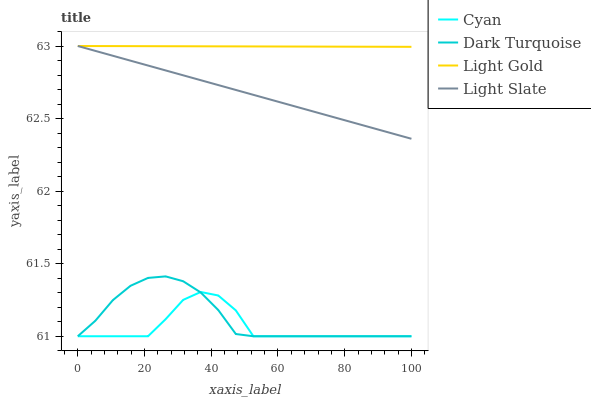Does Cyan have the minimum area under the curve?
Answer yes or no. Yes. Does Light Gold have the maximum area under the curve?
Answer yes or no. Yes. Does Light Gold have the minimum area under the curve?
Answer yes or no. No. Does Cyan have the maximum area under the curve?
Answer yes or no. No. Is Light Slate the smoothest?
Answer yes or no. Yes. Is Cyan the roughest?
Answer yes or no. Yes. Is Light Gold the smoothest?
Answer yes or no. No. Is Light Gold the roughest?
Answer yes or no. No. Does Cyan have the lowest value?
Answer yes or no. Yes. Does Light Gold have the lowest value?
Answer yes or no. No. Does Light Gold have the highest value?
Answer yes or no. Yes. Does Cyan have the highest value?
Answer yes or no. No. Is Dark Turquoise less than Light Gold?
Answer yes or no. Yes. Is Light Gold greater than Dark Turquoise?
Answer yes or no. Yes. Does Light Slate intersect Light Gold?
Answer yes or no. Yes. Is Light Slate less than Light Gold?
Answer yes or no. No. Is Light Slate greater than Light Gold?
Answer yes or no. No. Does Dark Turquoise intersect Light Gold?
Answer yes or no. No. 